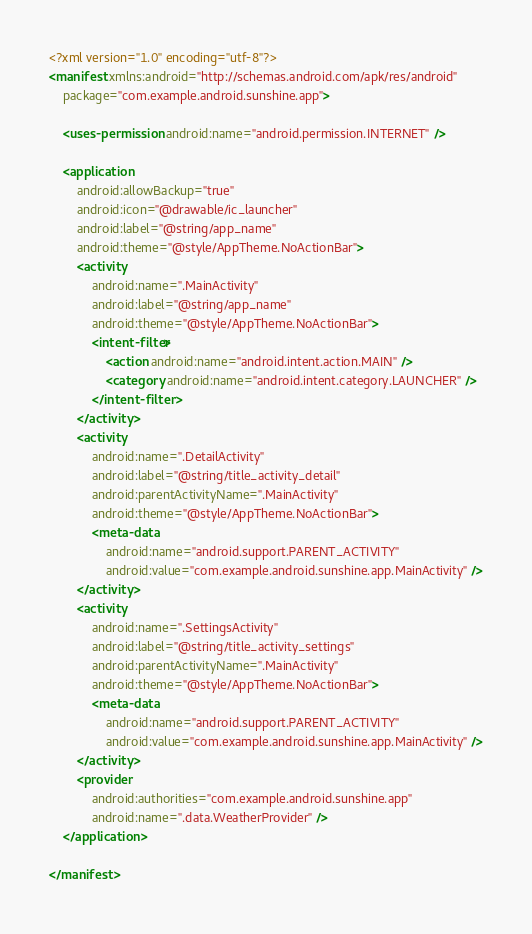<code> <loc_0><loc_0><loc_500><loc_500><_XML_><?xml version="1.0" encoding="utf-8"?>
<manifest xmlns:android="http://schemas.android.com/apk/res/android"
    package="com.example.android.sunshine.app">

    <uses-permission android:name="android.permission.INTERNET" />

    <application
        android:allowBackup="true"
        android:icon="@drawable/ic_launcher"
        android:label="@string/app_name"
        android:theme="@style/AppTheme.NoActionBar">
        <activity
            android:name=".MainActivity"
            android:label="@string/app_name"
            android:theme="@style/AppTheme.NoActionBar">
            <intent-filter>
                <action android:name="android.intent.action.MAIN" />
                <category android:name="android.intent.category.LAUNCHER" />
            </intent-filter>
        </activity>
        <activity
            android:name=".DetailActivity"
            android:label="@string/title_activity_detail"
            android:parentActivityName=".MainActivity"
            android:theme="@style/AppTheme.NoActionBar">
            <meta-data
                android:name="android.support.PARENT_ACTIVITY"
                android:value="com.example.android.sunshine.app.MainActivity" />
        </activity>
        <activity
            android:name=".SettingsActivity"
            android:label="@string/title_activity_settings"
            android:parentActivityName=".MainActivity"
            android:theme="@style/AppTheme.NoActionBar">
            <meta-data
                android:name="android.support.PARENT_ACTIVITY"
                android:value="com.example.android.sunshine.app.MainActivity" />
        </activity>
        <provider
            android:authorities="com.example.android.sunshine.app"
            android:name=".data.WeatherProvider" />
    </application>

</manifest>
</code> 